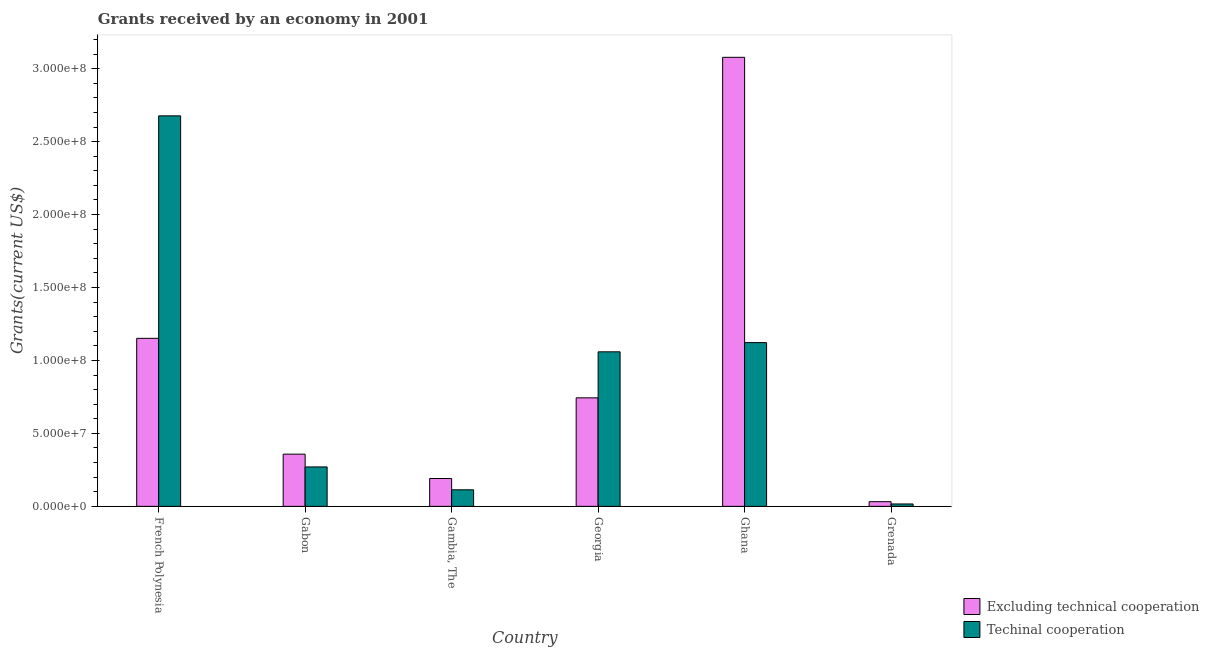How many groups of bars are there?
Provide a short and direct response. 6. Are the number of bars per tick equal to the number of legend labels?
Offer a terse response. Yes. Are the number of bars on each tick of the X-axis equal?
Offer a very short reply. Yes. How many bars are there on the 4th tick from the right?
Offer a very short reply. 2. What is the label of the 1st group of bars from the left?
Give a very brief answer. French Polynesia. What is the amount of grants received(excluding technical cooperation) in Gambia, The?
Provide a succinct answer. 1.91e+07. Across all countries, what is the maximum amount of grants received(including technical cooperation)?
Your response must be concise. 2.68e+08. Across all countries, what is the minimum amount of grants received(including technical cooperation)?
Your response must be concise. 1.63e+06. In which country was the amount of grants received(including technical cooperation) maximum?
Keep it short and to the point. French Polynesia. In which country was the amount of grants received(including technical cooperation) minimum?
Your answer should be compact. Grenada. What is the total amount of grants received(excluding technical cooperation) in the graph?
Your response must be concise. 5.55e+08. What is the difference between the amount of grants received(including technical cooperation) in French Polynesia and that in Grenada?
Your answer should be compact. 2.66e+08. What is the difference between the amount of grants received(including technical cooperation) in Ghana and the amount of grants received(excluding technical cooperation) in Gabon?
Your answer should be very brief. 7.64e+07. What is the average amount of grants received(including technical cooperation) per country?
Give a very brief answer. 8.76e+07. What is the difference between the amount of grants received(excluding technical cooperation) and amount of grants received(including technical cooperation) in French Polynesia?
Offer a very short reply. -1.52e+08. In how many countries, is the amount of grants received(excluding technical cooperation) greater than 100000000 US$?
Ensure brevity in your answer.  2. What is the ratio of the amount of grants received(excluding technical cooperation) in Gabon to that in Georgia?
Ensure brevity in your answer.  0.48. Is the amount of grants received(excluding technical cooperation) in Gambia, The less than that in Grenada?
Keep it short and to the point. No. What is the difference between the highest and the second highest amount of grants received(including technical cooperation)?
Make the answer very short. 1.55e+08. What is the difference between the highest and the lowest amount of grants received(including technical cooperation)?
Keep it short and to the point. 2.66e+08. What does the 1st bar from the left in Georgia represents?
Your response must be concise. Excluding technical cooperation. What does the 2nd bar from the right in Gabon represents?
Provide a short and direct response. Excluding technical cooperation. Are all the bars in the graph horizontal?
Keep it short and to the point. No. How many countries are there in the graph?
Your answer should be very brief. 6. What is the difference between two consecutive major ticks on the Y-axis?
Offer a very short reply. 5.00e+07. Are the values on the major ticks of Y-axis written in scientific E-notation?
Provide a short and direct response. Yes. Where does the legend appear in the graph?
Keep it short and to the point. Bottom right. How many legend labels are there?
Offer a very short reply. 2. What is the title of the graph?
Your response must be concise. Grants received by an economy in 2001. What is the label or title of the X-axis?
Ensure brevity in your answer.  Country. What is the label or title of the Y-axis?
Provide a short and direct response. Grants(current US$). What is the Grants(current US$) in Excluding technical cooperation in French Polynesia?
Offer a very short reply. 1.15e+08. What is the Grants(current US$) of Techinal cooperation in French Polynesia?
Keep it short and to the point. 2.68e+08. What is the Grants(current US$) of Excluding technical cooperation in Gabon?
Provide a short and direct response. 3.58e+07. What is the Grants(current US$) in Techinal cooperation in Gabon?
Ensure brevity in your answer.  2.70e+07. What is the Grants(current US$) in Excluding technical cooperation in Gambia, The?
Provide a short and direct response. 1.91e+07. What is the Grants(current US$) in Techinal cooperation in Gambia, The?
Provide a short and direct response. 1.13e+07. What is the Grants(current US$) in Excluding technical cooperation in Georgia?
Provide a succinct answer. 7.44e+07. What is the Grants(current US$) in Techinal cooperation in Georgia?
Ensure brevity in your answer.  1.06e+08. What is the Grants(current US$) in Excluding technical cooperation in Ghana?
Give a very brief answer. 3.08e+08. What is the Grants(current US$) in Techinal cooperation in Ghana?
Your answer should be very brief. 1.12e+08. What is the Grants(current US$) of Excluding technical cooperation in Grenada?
Ensure brevity in your answer.  3.20e+06. What is the Grants(current US$) of Techinal cooperation in Grenada?
Provide a succinct answer. 1.63e+06. Across all countries, what is the maximum Grants(current US$) in Excluding technical cooperation?
Provide a succinct answer. 3.08e+08. Across all countries, what is the maximum Grants(current US$) of Techinal cooperation?
Offer a terse response. 2.68e+08. Across all countries, what is the minimum Grants(current US$) in Excluding technical cooperation?
Offer a very short reply. 3.20e+06. Across all countries, what is the minimum Grants(current US$) in Techinal cooperation?
Your answer should be very brief. 1.63e+06. What is the total Grants(current US$) of Excluding technical cooperation in the graph?
Offer a terse response. 5.55e+08. What is the total Grants(current US$) of Techinal cooperation in the graph?
Give a very brief answer. 5.26e+08. What is the difference between the Grants(current US$) in Excluding technical cooperation in French Polynesia and that in Gabon?
Ensure brevity in your answer.  7.94e+07. What is the difference between the Grants(current US$) in Techinal cooperation in French Polynesia and that in Gabon?
Your answer should be very brief. 2.41e+08. What is the difference between the Grants(current US$) of Excluding technical cooperation in French Polynesia and that in Gambia, The?
Offer a terse response. 9.61e+07. What is the difference between the Grants(current US$) of Techinal cooperation in French Polynesia and that in Gambia, The?
Give a very brief answer. 2.56e+08. What is the difference between the Grants(current US$) of Excluding technical cooperation in French Polynesia and that in Georgia?
Offer a very short reply. 4.08e+07. What is the difference between the Grants(current US$) in Techinal cooperation in French Polynesia and that in Georgia?
Offer a very short reply. 1.62e+08. What is the difference between the Grants(current US$) of Excluding technical cooperation in French Polynesia and that in Ghana?
Your response must be concise. -1.93e+08. What is the difference between the Grants(current US$) in Techinal cooperation in French Polynesia and that in Ghana?
Offer a very short reply. 1.55e+08. What is the difference between the Grants(current US$) in Excluding technical cooperation in French Polynesia and that in Grenada?
Offer a terse response. 1.12e+08. What is the difference between the Grants(current US$) in Techinal cooperation in French Polynesia and that in Grenada?
Give a very brief answer. 2.66e+08. What is the difference between the Grants(current US$) in Excluding technical cooperation in Gabon and that in Gambia, The?
Ensure brevity in your answer.  1.67e+07. What is the difference between the Grants(current US$) in Techinal cooperation in Gabon and that in Gambia, The?
Your answer should be compact. 1.57e+07. What is the difference between the Grants(current US$) in Excluding technical cooperation in Gabon and that in Georgia?
Provide a succinct answer. -3.86e+07. What is the difference between the Grants(current US$) in Techinal cooperation in Gabon and that in Georgia?
Offer a very short reply. -7.89e+07. What is the difference between the Grants(current US$) in Excluding technical cooperation in Gabon and that in Ghana?
Offer a terse response. -2.72e+08. What is the difference between the Grants(current US$) of Techinal cooperation in Gabon and that in Ghana?
Make the answer very short. -8.52e+07. What is the difference between the Grants(current US$) in Excluding technical cooperation in Gabon and that in Grenada?
Your answer should be compact. 3.26e+07. What is the difference between the Grants(current US$) in Techinal cooperation in Gabon and that in Grenada?
Your response must be concise. 2.54e+07. What is the difference between the Grants(current US$) in Excluding technical cooperation in Gambia, The and that in Georgia?
Your answer should be very brief. -5.53e+07. What is the difference between the Grants(current US$) of Techinal cooperation in Gambia, The and that in Georgia?
Provide a short and direct response. -9.46e+07. What is the difference between the Grants(current US$) of Excluding technical cooperation in Gambia, The and that in Ghana?
Your answer should be compact. -2.89e+08. What is the difference between the Grants(current US$) of Techinal cooperation in Gambia, The and that in Ghana?
Make the answer very short. -1.01e+08. What is the difference between the Grants(current US$) in Excluding technical cooperation in Gambia, The and that in Grenada?
Your answer should be compact. 1.59e+07. What is the difference between the Grants(current US$) of Techinal cooperation in Gambia, The and that in Grenada?
Your answer should be very brief. 9.71e+06. What is the difference between the Grants(current US$) of Excluding technical cooperation in Georgia and that in Ghana?
Ensure brevity in your answer.  -2.33e+08. What is the difference between the Grants(current US$) in Techinal cooperation in Georgia and that in Ghana?
Provide a short and direct response. -6.31e+06. What is the difference between the Grants(current US$) of Excluding technical cooperation in Georgia and that in Grenada?
Give a very brief answer. 7.12e+07. What is the difference between the Grants(current US$) in Techinal cooperation in Georgia and that in Grenada?
Provide a succinct answer. 1.04e+08. What is the difference between the Grants(current US$) of Excluding technical cooperation in Ghana and that in Grenada?
Offer a very short reply. 3.05e+08. What is the difference between the Grants(current US$) of Techinal cooperation in Ghana and that in Grenada?
Provide a succinct answer. 1.11e+08. What is the difference between the Grants(current US$) of Excluding technical cooperation in French Polynesia and the Grants(current US$) of Techinal cooperation in Gabon?
Provide a succinct answer. 8.81e+07. What is the difference between the Grants(current US$) in Excluding technical cooperation in French Polynesia and the Grants(current US$) in Techinal cooperation in Gambia, The?
Your answer should be compact. 1.04e+08. What is the difference between the Grants(current US$) of Excluding technical cooperation in French Polynesia and the Grants(current US$) of Techinal cooperation in Georgia?
Your response must be concise. 9.24e+06. What is the difference between the Grants(current US$) in Excluding technical cooperation in French Polynesia and the Grants(current US$) in Techinal cooperation in Ghana?
Provide a short and direct response. 2.93e+06. What is the difference between the Grants(current US$) of Excluding technical cooperation in French Polynesia and the Grants(current US$) of Techinal cooperation in Grenada?
Keep it short and to the point. 1.14e+08. What is the difference between the Grants(current US$) of Excluding technical cooperation in Gabon and the Grants(current US$) of Techinal cooperation in Gambia, The?
Your answer should be very brief. 2.44e+07. What is the difference between the Grants(current US$) in Excluding technical cooperation in Gabon and the Grants(current US$) in Techinal cooperation in Georgia?
Provide a succinct answer. -7.01e+07. What is the difference between the Grants(current US$) of Excluding technical cooperation in Gabon and the Grants(current US$) of Techinal cooperation in Ghana?
Offer a very short reply. -7.64e+07. What is the difference between the Grants(current US$) of Excluding technical cooperation in Gabon and the Grants(current US$) of Techinal cooperation in Grenada?
Provide a short and direct response. 3.42e+07. What is the difference between the Grants(current US$) in Excluding technical cooperation in Gambia, The and the Grants(current US$) in Techinal cooperation in Georgia?
Give a very brief answer. -8.68e+07. What is the difference between the Grants(current US$) in Excluding technical cooperation in Gambia, The and the Grants(current US$) in Techinal cooperation in Ghana?
Give a very brief answer. -9.32e+07. What is the difference between the Grants(current US$) in Excluding technical cooperation in Gambia, The and the Grants(current US$) in Techinal cooperation in Grenada?
Your answer should be very brief. 1.74e+07. What is the difference between the Grants(current US$) of Excluding technical cooperation in Georgia and the Grants(current US$) of Techinal cooperation in Ghana?
Make the answer very short. -3.78e+07. What is the difference between the Grants(current US$) of Excluding technical cooperation in Georgia and the Grants(current US$) of Techinal cooperation in Grenada?
Offer a terse response. 7.28e+07. What is the difference between the Grants(current US$) of Excluding technical cooperation in Ghana and the Grants(current US$) of Techinal cooperation in Grenada?
Make the answer very short. 3.06e+08. What is the average Grants(current US$) of Excluding technical cooperation per country?
Make the answer very short. 9.26e+07. What is the average Grants(current US$) in Techinal cooperation per country?
Your answer should be very brief. 8.76e+07. What is the difference between the Grants(current US$) in Excluding technical cooperation and Grants(current US$) in Techinal cooperation in French Polynesia?
Provide a short and direct response. -1.52e+08. What is the difference between the Grants(current US$) of Excluding technical cooperation and Grants(current US$) of Techinal cooperation in Gabon?
Provide a succinct answer. 8.76e+06. What is the difference between the Grants(current US$) of Excluding technical cooperation and Grants(current US$) of Techinal cooperation in Gambia, The?
Your response must be concise. 7.74e+06. What is the difference between the Grants(current US$) in Excluding technical cooperation and Grants(current US$) in Techinal cooperation in Georgia?
Offer a terse response. -3.15e+07. What is the difference between the Grants(current US$) in Excluding technical cooperation and Grants(current US$) in Techinal cooperation in Ghana?
Your answer should be compact. 1.96e+08. What is the difference between the Grants(current US$) of Excluding technical cooperation and Grants(current US$) of Techinal cooperation in Grenada?
Provide a short and direct response. 1.57e+06. What is the ratio of the Grants(current US$) of Excluding technical cooperation in French Polynesia to that in Gabon?
Provide a short and direct response. 3.22. What is the ratio of the Grants(current US$) in Techinal cooperation in French Polynesia to that in Gabon?
Offer a very short reply. 9.91. What is the ratio of the Grants(current US$) in Excluding technical cooperation in French Polynesia to that in Gambia, The?
Your answer should be very brief. 6.04. What is the ratio of the Grants(current US$) of Techinal cooperation in French Polynesia to that in Gambia, The?
Keep it short and to the point. 23.6. What is the ratio of the Grants(current US$) of Excluding technical cooperation in French Polynesia to that in Georgia?
Your answer should be compact. 1.55. What is the ratio of the Grants(current US$) in Techinal cooperation in French Polynesia to that in Georgia?
Keep it short and to the point. 2.53. What is the ratio of the Grants(current US$) in Excluding technical cooperation in French Polynesia to that in Ghana?
Your answer should be compact. 0.37. What is the ratio of the Grants(current US$) of Techinal cooperation in French Polynesia to that in Ghana?
Offer a very short reply. 2.38. What is the ratio of the Grants(current US$) in Excluding technical cooperation in French Polynesia to that in Grenada?
Your answer should be compact. 35.99. What is the ratio of the Grants(current US$) in Techinal cooperation in French Polynesia to that in Grenada?
Give a very brief answer. 164.21. What is the ratio of the Grants(current US$) of Excluding technical cooperation in Gabon to that in Gambia, The?
Your response must be concise. 1.88. What is the ratio of the Grants(current US$) in Techinal cooperation in Gabon to that in Gambia, The?
Provide a succinct answer. 2.38. What is the ratio of the Grants(current US$) in Excluding technical cooperation in Gabon to that in Georgia?
Your answer should be very brief. 0.48. What is the ratio of the Grants(current US$) in Techinal cooperation in Gabon to that in Georgia?
Your answer should be very brief. 0.26. What is the ratio of the Grants(current US$) in Excluding technical cooperation in Gabon to that in Ghana?
Your answer should be very brief. 0.12. What is the ratio of the Grants(current US$) in Techinal cooperation in Gabon to that in Ghana?
Offer a very short reply. 0.24. What is the ratio of the Grants(current US$) in Excluding technical cooperation in Gabon to that in Grenada?
Offer a very short reply. 11.18. What is the ratio of the Grants(current US$) in Techinal cooperation in Gabon to that in Grenada?
Provide a short and direct response. 16.58. What is the ratio of the Grants(current US$) in Excluding technical cooperation in Gambia, The to that in Georgia?
Offer a terse response. 0.26. What is the ratio of the Grants(current US$) in Techinal cooperation in Gambia, The to that in Georgia?
Your answer should be compact. 0.11. What is the ratio of the Grants(current US$) of Excluding technical cooperation in Gambia, The to that in Ghana?
Provide a succinct answer. 0.06. What is the ratio of the Grants(current US$) in Techinal cooperation in Gambia, The to that in Ghana?
Offer a very short reply. 0.1. What is the ratio of the Grants(current US$) in Excluding technical cooperation in Gambia, The to that in Grenada?
Your response must be concise. 5.96. What is the ratio of the Grants(current US$) of Techinal cooperation in Gambia, The to that in Grenada?
Give a very brief answer. 6.96. What is the ratio of the Grants(current US$) of Excluding technical cooperation in Georgia to that in Ghana?
Provide a short and direct response. 0.24. What is the ratio of the Grants(current US$) of Techinal cooperation in Georgia to that in Ghana?
Your answer should be compact. 0.94. What is the ratio of the Grants(current US$) of Excluding technical cooperation in Georgia to that in Grenada?
Offer a very short reply. 23.24. What is the ratio of the Grants(current US$) in Techinal cooperation in Georgia to that in Grenada?
Your answer should be compact. 64.98. What is the ratio of the Grants(current US$) in Excluding technical cooperation in Ghana to that in Grenada?
Provide a succinct answer. 96.18. What is the ratio of the Grants(current US$) in Techinal cooperation in Ghana to that in Grenada?
Ensure brevity in your answer.  68.85. What is the difference between the highest and the second highest Grants(current US$) of Excluding technical cooperation?
Offer a terse response. 1.93e+08. What is the difference between the highest and the second highest Grants(current US$) of Techinal cooperation?
Provide a short and direct response. 1.55e+08. What is the difference between the highest and the lowest Grants(current US$) of Excluding technical cooperation?
Your answer should be very brief. 3.05e+08. What is the difference between the highest and the lowest Grants(current US$) in Techinal cooperation?
Provide a succinct answer. 2.66e+08. 